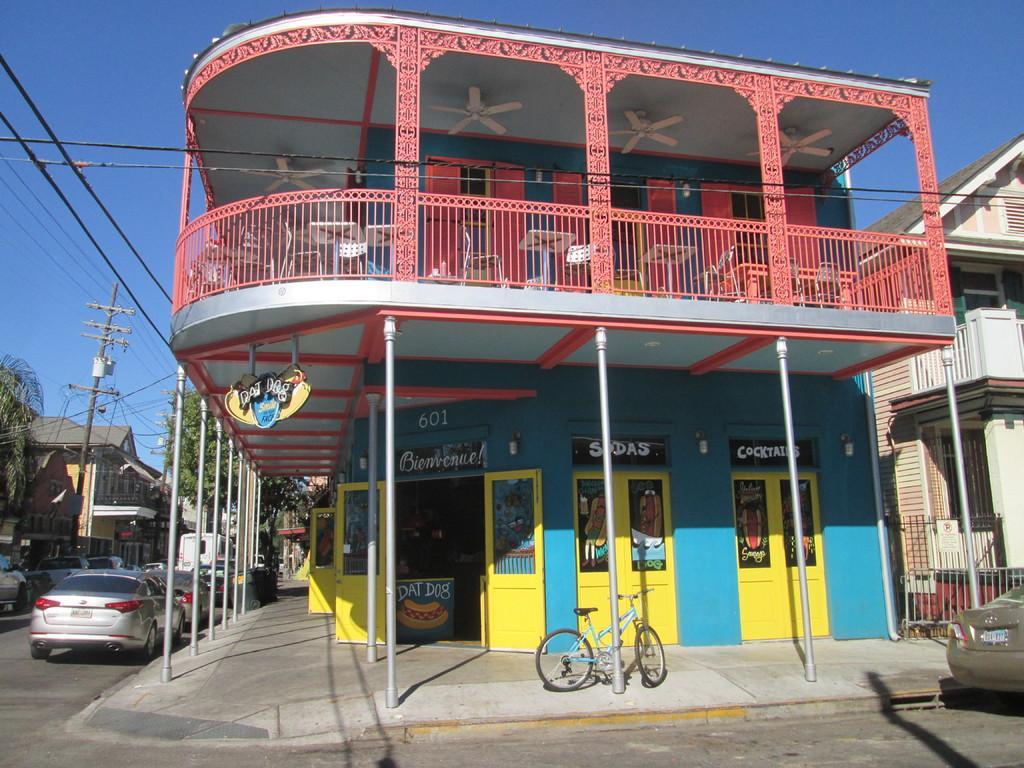Could you give a brief overview of what you see in this image? In this picture I can see many buildings. At the bottom there is a bicycle which is parked near to the poles and doors. On the left I can see many cars which are parked on the road, beside that I can see the electric poles and trees. On the left I can see many electrical wires. At the top I can see the sky. On the roof of the building I can see the fans. 